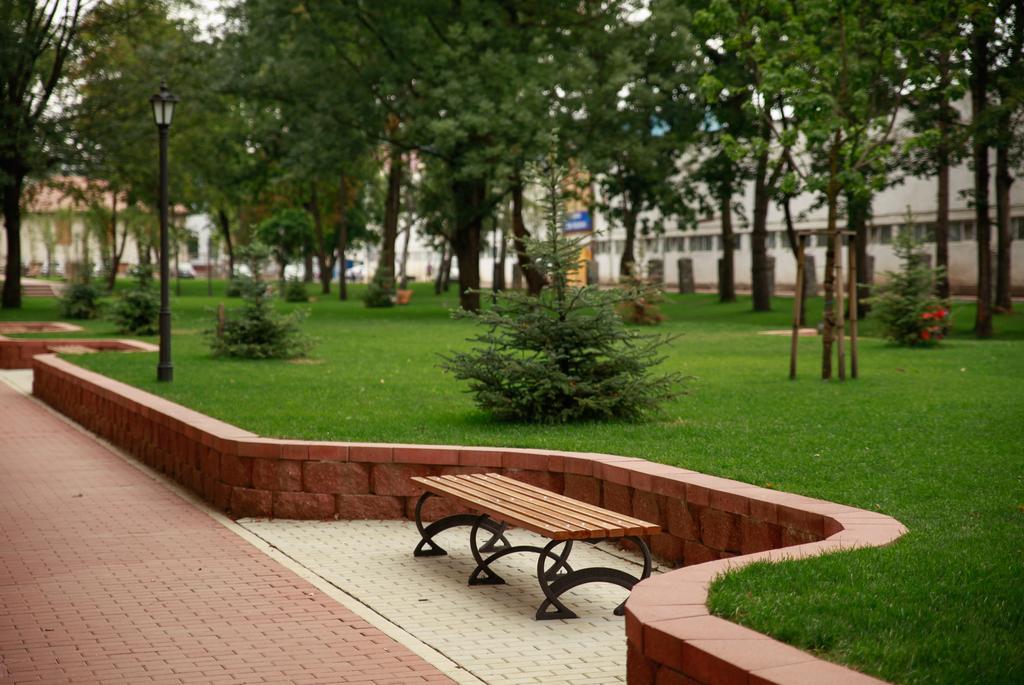Describe this image in one or two sentences. In this picture there is a bench near to the wall. On the left there is a street light near to the plants and grass. In the background we can see buildings and trees. In the top left there is a sky. 